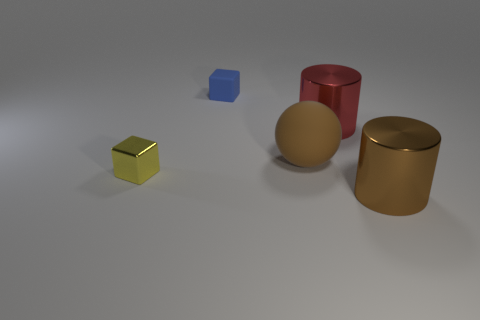What material is the big object in front of the rubber object on the right side of the blue matte block?
Your answer should be very brief. Metal. What number of small rubber things are the same color as the big matte sphere?
Give a very brief answer. 0. What size is the blue thing that is the same material as the big ball?
Ensure brevity in your answer.  Small. What shape is the big metal thing that is on the left side of the brown cylinder?
Give a very brief answer. Cylinder. There is a blue rubber object that is the same shape as the tiny yellow thing; what size is it?
Your response must be concise. Small. How many blue cubes are on the left side of the large cylinder that is on the left side of the large metal object that is right of the red shiny cylinder?
Offer a very short reply. 1. Is the number of large things that are behind the red thing the same as the number of large brown cylinders?
Your answer should be compact. No. How many blocks are either small shiny objects or small objects?
Offer a terse response. 2. Do the small rubber object and the sphere have the same color?
Offer a terse response. No. Are there an equal number of blue cubes on the right side of the large red thing and yellow things on the right side of the tiny blue rubber object?
Your answer should be compact. Yes. 